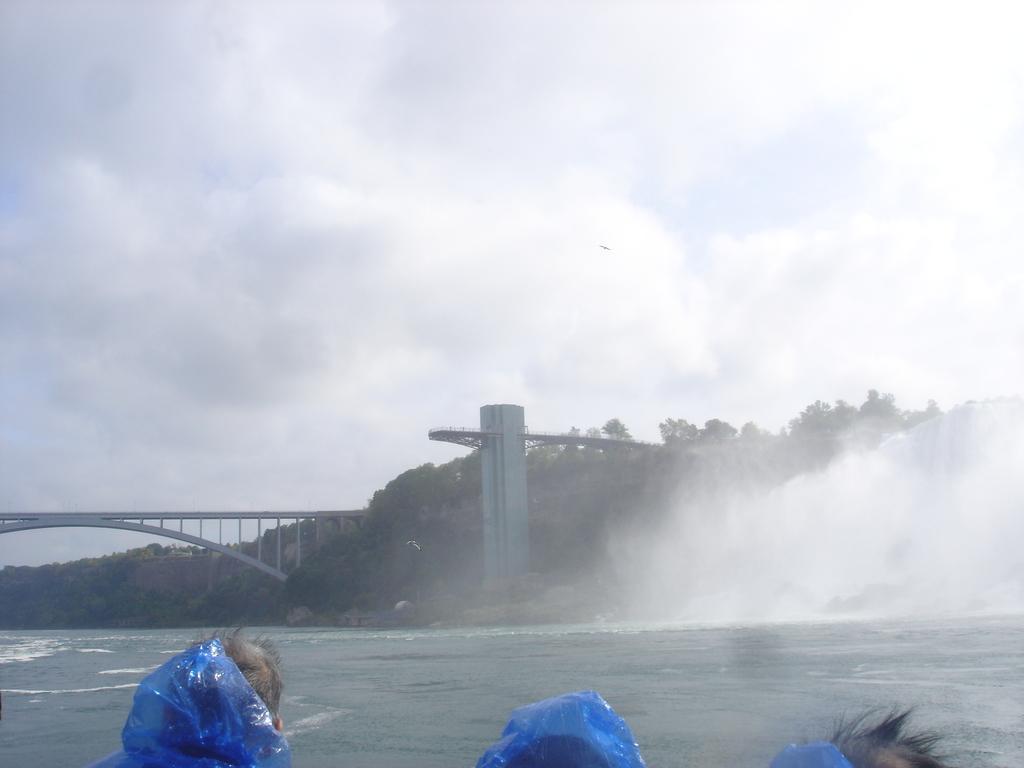How would you summarize this image in a sentence or two? This image consists of three persons. At the bottom, there is water. In the front, we can see a bridge along with trees. At the top, there are clouds in the sky. 